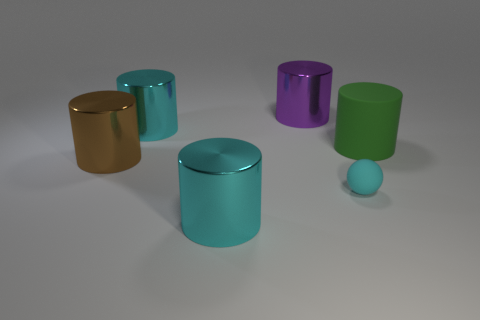Subtract all cyan cylinders. How many cylinders are left? 3 Subtract all big brown cylinders. How many cylinders are left? 4 Subtract 1 cylinders. How many cylinders are left? 4 Subtract all yellow cylinders. Subtract all gray balls. How many cylinders are left? 5 Add 2 tiny cyan matte balls. How many objects exist? 8 Subtract all cylinders. How many objects are left? 1 Add 5 tiny green shiny cylinders. How many tiny green shiny cylinders exist? 5 Subtract 1 purple cylinders. How many objects are left? 5 Subtract all purple cylinders. Subtract all big brown metal objects. How many objects are left? 4 Add 1 big green rubber objects. How many big green rubber objects are left? 2 